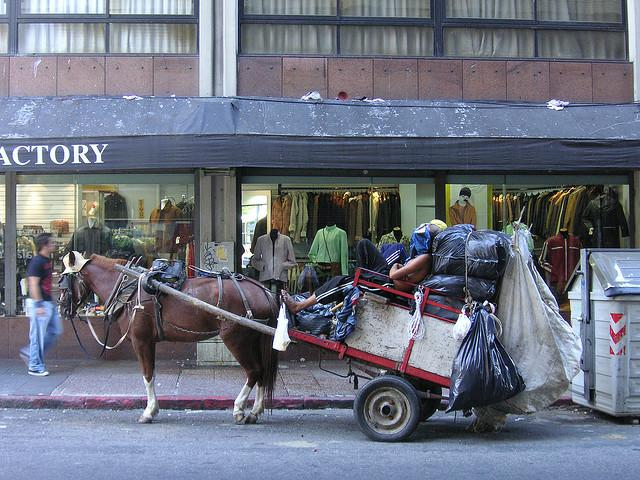What item here makes the horse go forward focusing?

Choices:
A) shoes
B) garbage bags
C) blinders
D) hat blinders 